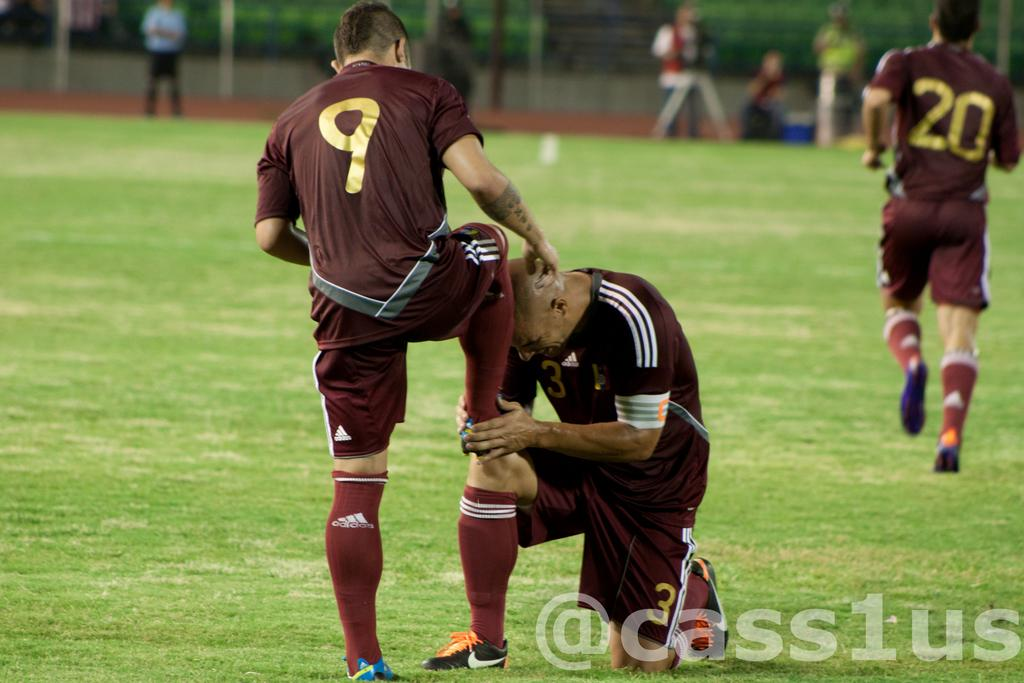How many people are in the image? There are people in the image, but the exact number is not specified. What is the position of the people in the image? The people are on the ground in the image. Can you describe the background of the image? The background of the image is blurred. What type of sense does the maid in the image possess? There is no mention of a maid or any specific sense in the image. 